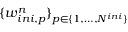<formula> <loc_0><loc_0><loc_500><loc_500>\{ w _ { i n i , p } ^ { n } \} _ { p \in \{ 1 , \dots , N ^ { i n i } \} }</formula> 